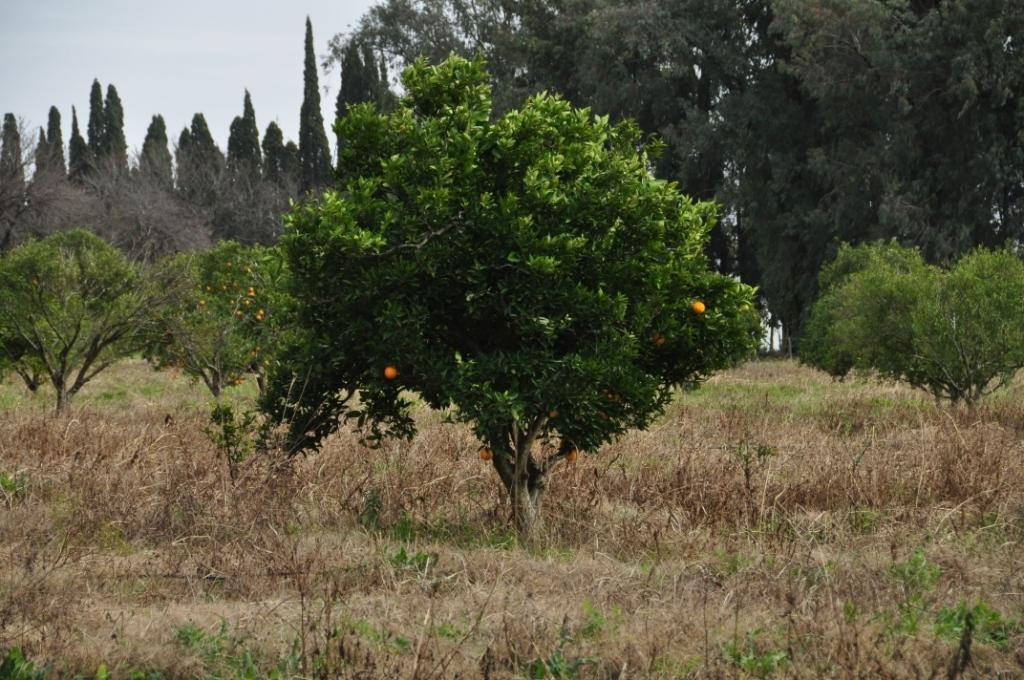What type of vegetation can be seen in the image? There is grass, plants, and many trees in the image. What type of fruits are present on the plants? There are orange color fruits on the plants. What can be seen in the background of the image? The sky is visible in the background of the image. What type of sheet is being used to cover the farm in the image? There is no farm or sheet present in the image. What type of business is being conducted in the image? The image does not depict any business activities. 